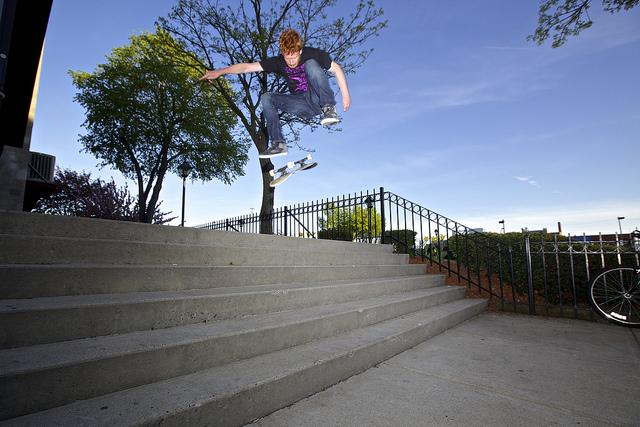If the skateboard kept this orientation how would his landing be?

Choices:
A) easy
B) normal
C) dangerous
D) soft dangerous 